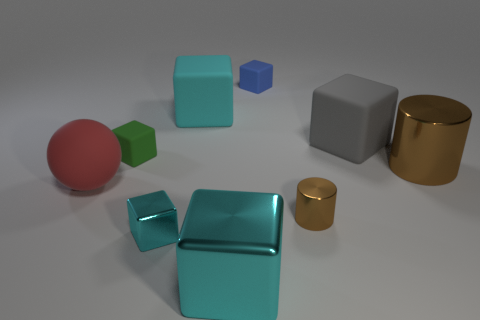How many cyan blocks must be subtracted to get 1 cyan blocks? 2 Subtract all big rubber cubes. How many cubes are left? 4 Add 1 cylinders. How many objects exist? 10 Subtract all cylinders. How many objects are left? 7 Subtract 1 blocks. How many blocks are left? 5 Subtract all purple cylinders. Subtract all red balls. How many cylinders are left? 2 Subtract all blue balls. How many cyan blocks are left? 3 Subtract all tiny blue cubes. Subtract all green matte things. How many objects are left? 7 Add 1 cyan rubber cubes. How many cyan rubber cubes are left? 2 Add 2 small green cubes. How many small green cubes exist? 3 